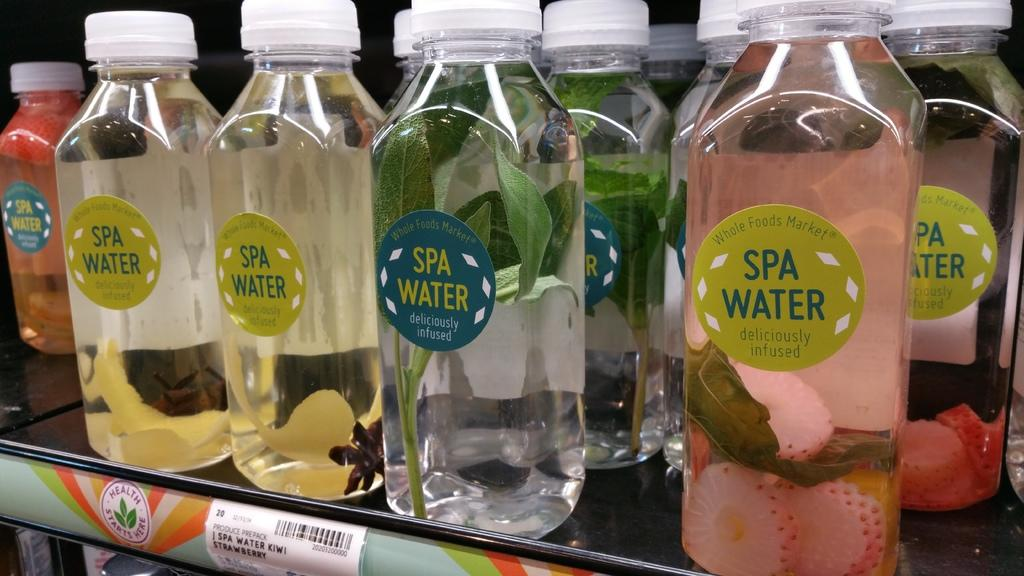<image>
Share a concise interpretation of the image provided. The water sits on a shelf that advertises health starts here. 